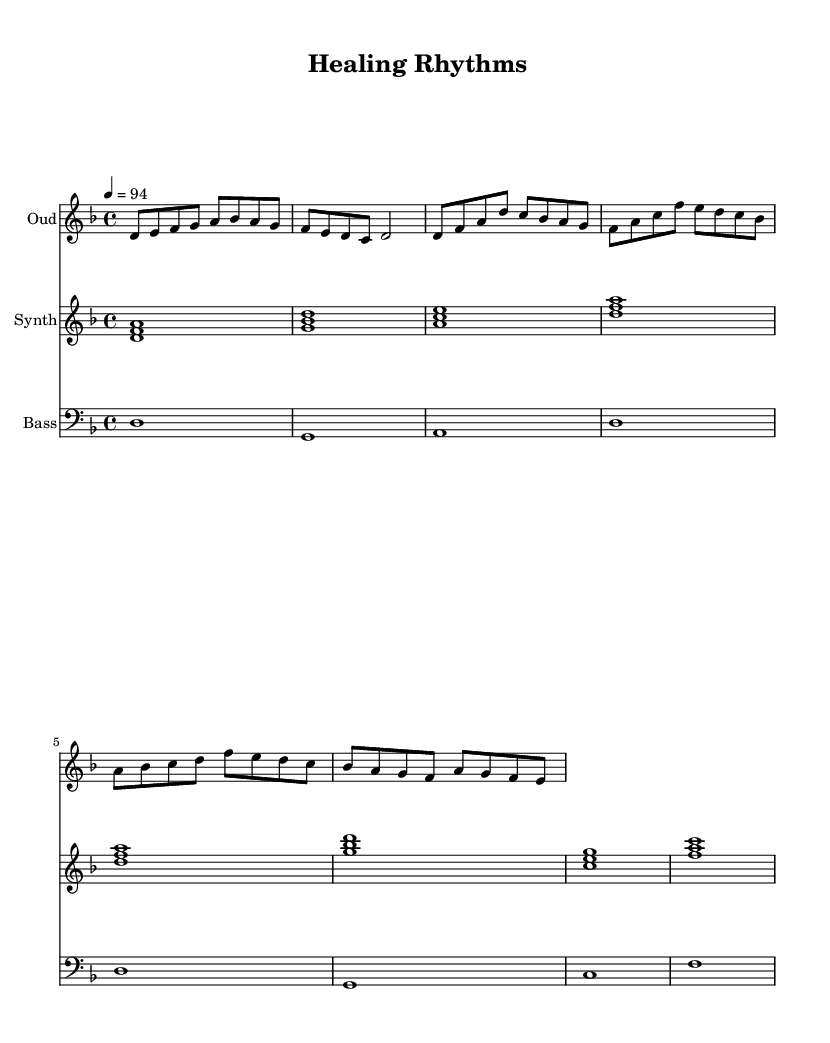What is the key signature of this music? The key signature is indicated by the flat symbol before the notes. There are two flat symbols present, which corresponds to B flat and E flat.
Answer: D minor What is the time signature of this music? The time signature is shown at the beginning of the music as “4/4”, meaning there are four beats in each measure, and the quarter note gets one beat.
Answer: 4/4 What is the tempo marking for this music? The tempo is indicated at the start with “4 = 94”, which means there are 94 beats per minute for the quarter note.
Answer: 94 How many measures are in the oud part? The total number of measures can be counted by looking at the bar lines in the oud part. There are eight measures present for the intro and verse sections combined.
Answer: 8 What is the harmonic structure of the synth part primarily based on? The synth part uses a series of triads, each of three notes, which are the root, third, and fifth of the chords. This harmonic structure is common in fusion music.
Answer: Triads Which instrument plays the melodic line in the first part of the music? The oud instrument, shown on the top staff, plays the introductory melodic line with various single notes.
Answer: Oud What specific sound characterizes the fusion aspect of this music? The combination of Middle Eastern melodies played by the oud with electronic synth pads creates a rich texture indicative of fusion jazz.
Answer: Electronic beats 